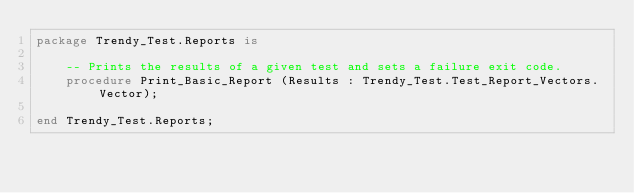Convert code to text. <code><loc_0><loc_0><loc_500><loc_500><_Ada_>package Trendy_Test.Reports is

    -- Prints the results of a given test and sets a failure exit code.
    procedure Print_Basic_Report (Results : Trendy_Test.Test_Report_Vectors.Vector);

end Trendy_Test.Reports;
</code> 